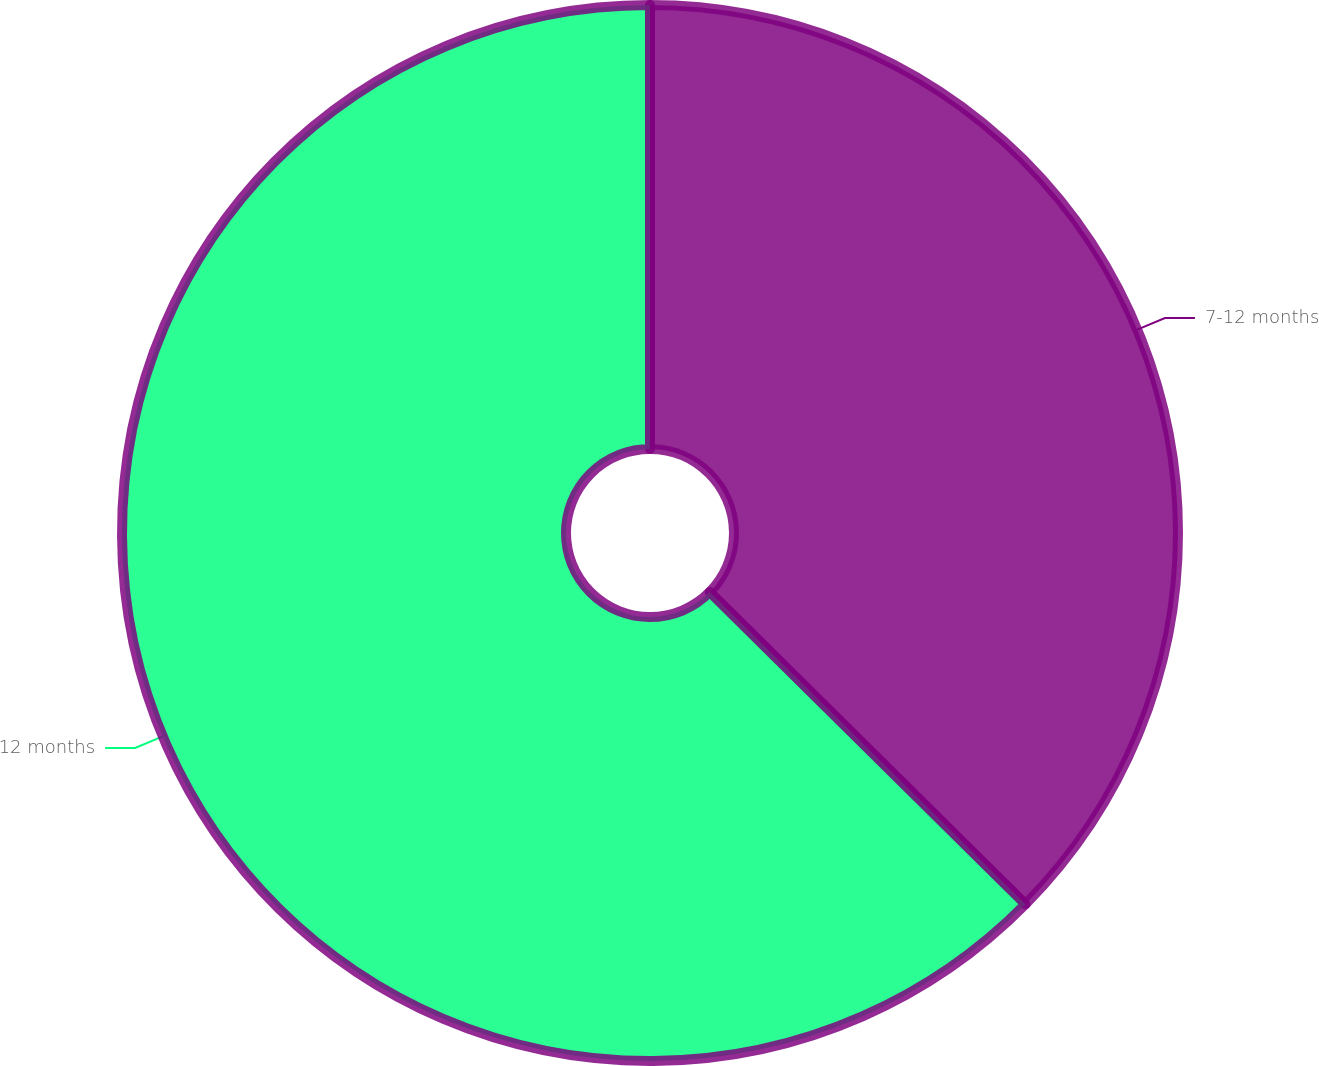<chart> <loc_0><loc_0><loc_500><loc_500><pie_chart><fcel>7-12 months<fcel>12 months<nl><fcel>37.41%<fcel>62.59%<nl></chart> 